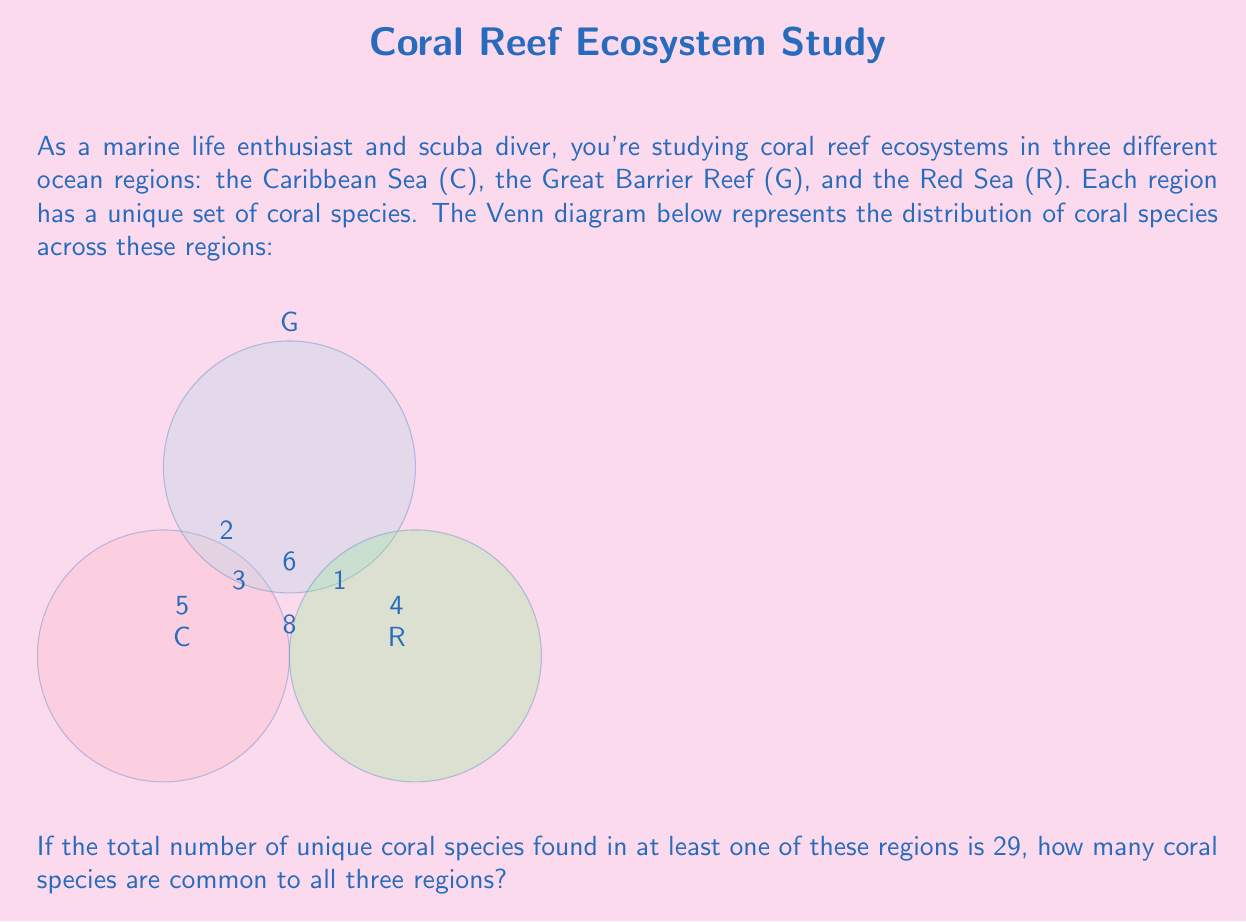Solve this math problem. Let's approach this step-by-step using set theory:

1) Let's define our sets:
   C: Caribbean Sea corals
   G: Great Barrier Reef corals
   R: Red Sea corals

2) From the Venn diagram, we can see:
   $|C \setminus (G \cup R)| = 5$
   $|G \setminus (C \cup R)| = 2$
   $|R \setminus (C \cup G)| = 4$
   $|C \cap G \setminus R| = 3$
   $|C \cap R \setminus G| = 8$
   $|G \cap R \setminus C| = 1$

3) Let $x$ be the number of coral species common to all three regions:
   $|C \cap G \cap R| = x$

4) We're told that the total number of unique coral species is 29. This is equivalent to $|C \cup G \cup R| = 29$

5) Using the inclusion-exclusion principle:
   $|C \cup G \cup R| = |C| + |G| + |R| - |C \cap G| - |C \cap R| - |G \cap R| + |C \cap G \cap R|$

6) Substituting the known values:
   $29 = (5+3+8+x) + (2+3+1+x) + (4+8+1+x) - (3+x) - (8+x) - (1+x) + x$

7) Simplifying:
   $29 = 16+x + 6+x + 13+x - 3-x - 8-x - 1-x + x$
   $29 = 35 + x$

8) Solving for x:
   $x = 29 - 35 = -6$

Therefore, there are 6 coral species common to all three regions.
Answer: 6 